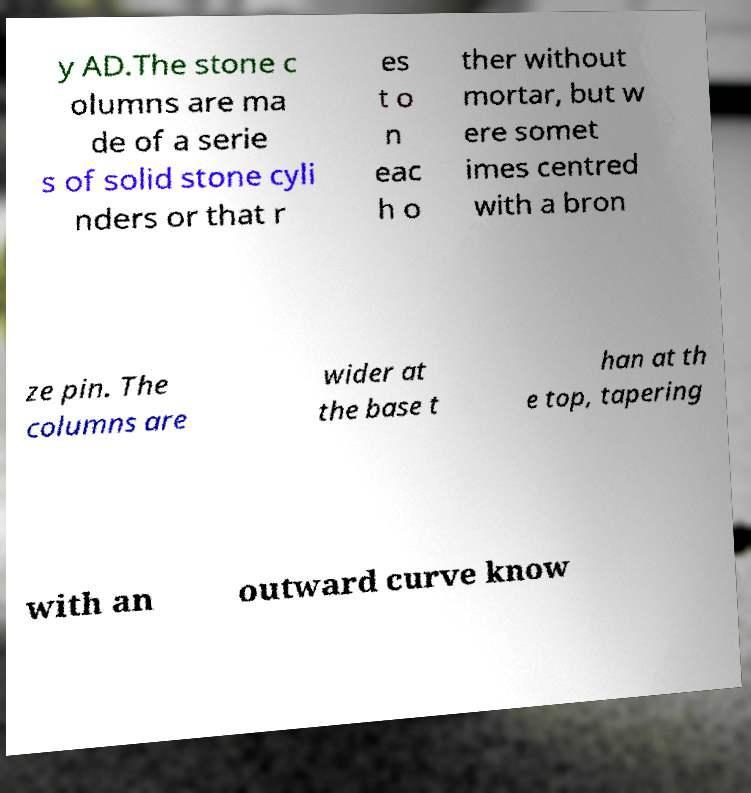Please read and relay the text visible in this image. What does it say? y AD.The stone c olumns are ma de of a serie s of solid stone cyli nders or that r es t o n eac h o ther without mortar, but w ere somet imes centred with a bron ze pin. The columns are wider at the base t han at th e top, tapering with an outward curve know 